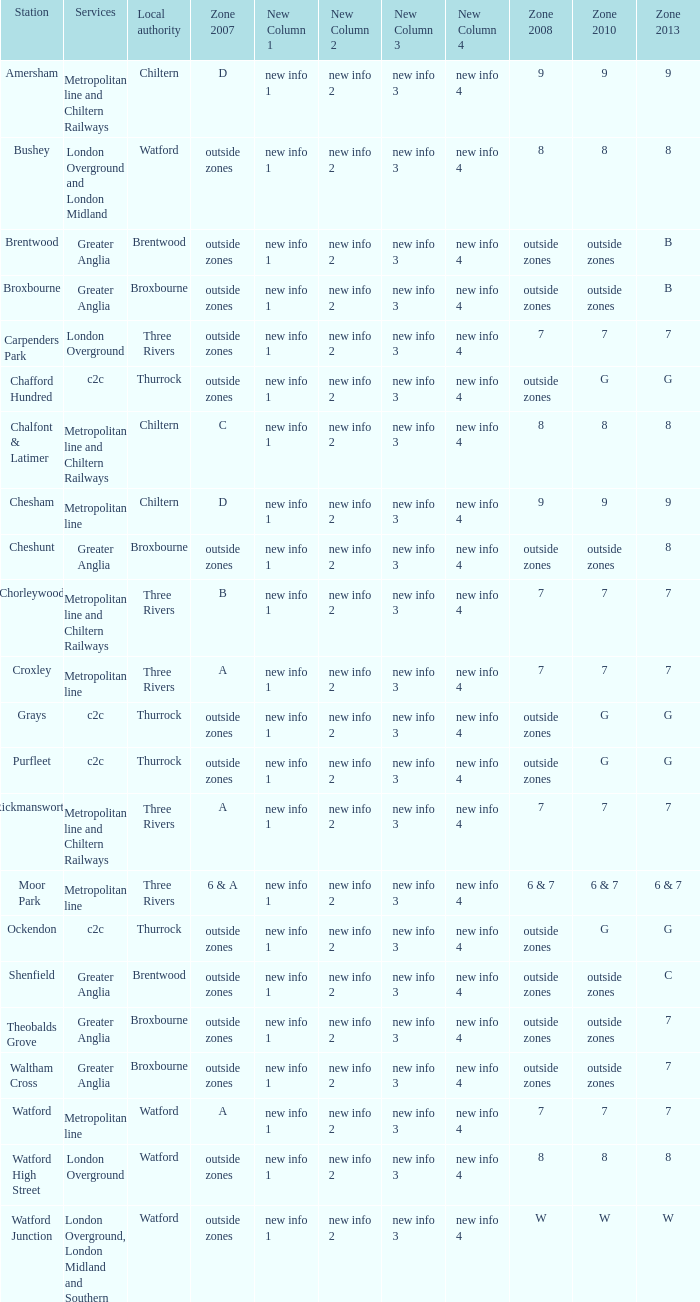Which Station has a Zone 2008 of 8, and a Zone 2007 of outside zones, and Services of london overground? Watford High Street. 